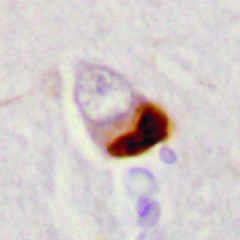re cytoplasmic inclusions containing tdp43 seen in association with loss of normal nuclear immunoreactivity?
Answer the question using a single word or phrase. Yes 